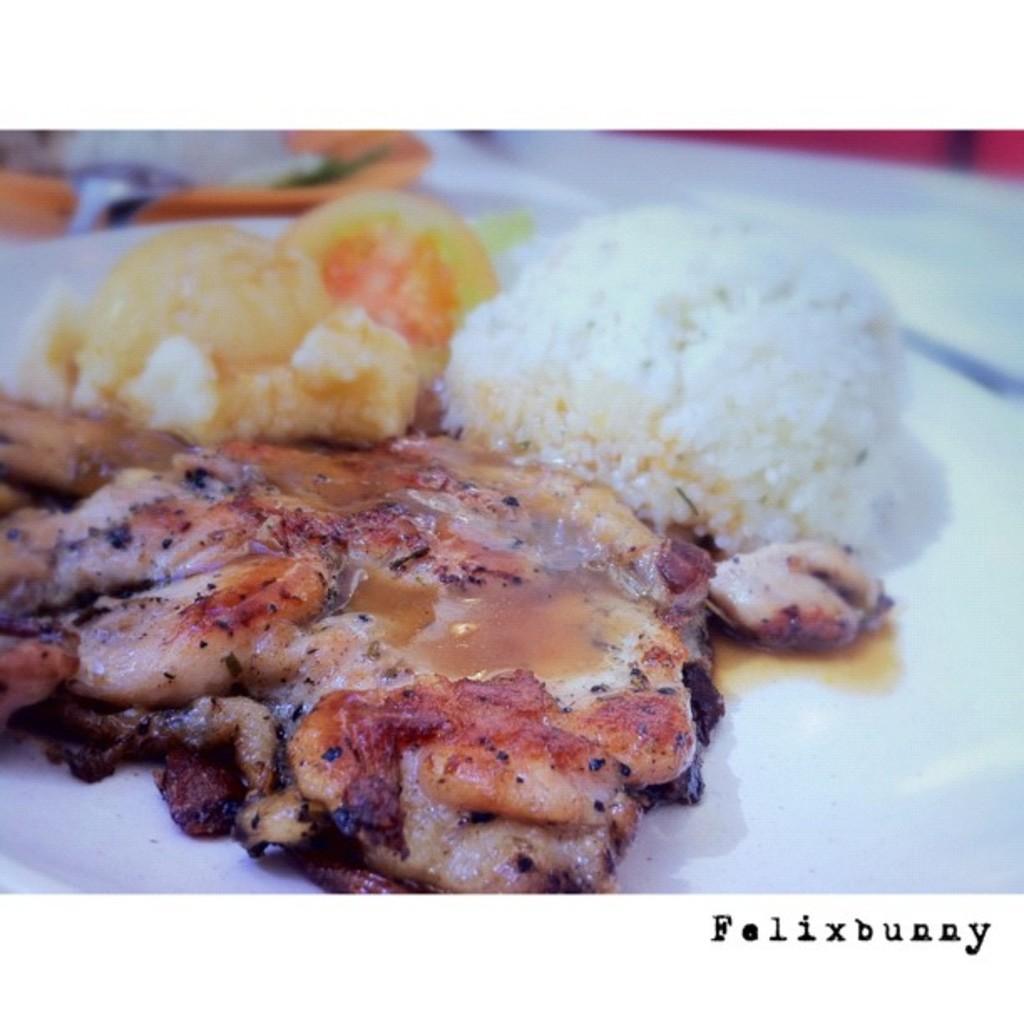Please provide a concise description of this image. In this image, I can see the meat and some other food items on the plate. This plate is white in color. This is the watermark on the image. 